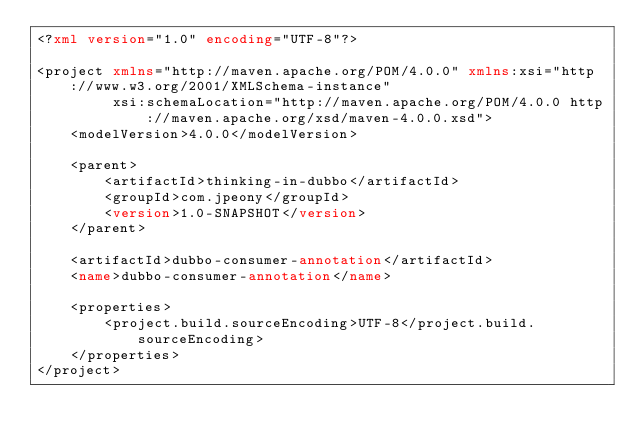Convert code to text. <code><loc_0><loc_0><loc_500><loc_500><_XML_><?xml version="1.0" encoding="UTF-8"?>

<project xmlns="http://maven.apache.org/POM/4.0.0" xmlns:xsi="http://www.w3.org/2001/XMLSchema-instance"
         xsi:schemaLocation="http://maven.apache.org/POM/4.0.0 http://maven.apache.org/xsd/maven-4.0.0.xsd">
    <modelVersion>4.0.0</modelVersion>

    <parent>
        <artifactId>thinking-in-dubbo</artifactId>
        <groupId>com.jpeony</groupId>
        <version>1.0-SNAPSHOT</version>
    </parent>

    <artifactId>dubbo-consumer-annotation</artifactId>
    <name>dubbo-consumer-annotation</name>

    <properties>
        <project.build.sourceEncoding>UTF-8</project.build.sourceEncoding>
    </properties>
</project>
</code> 